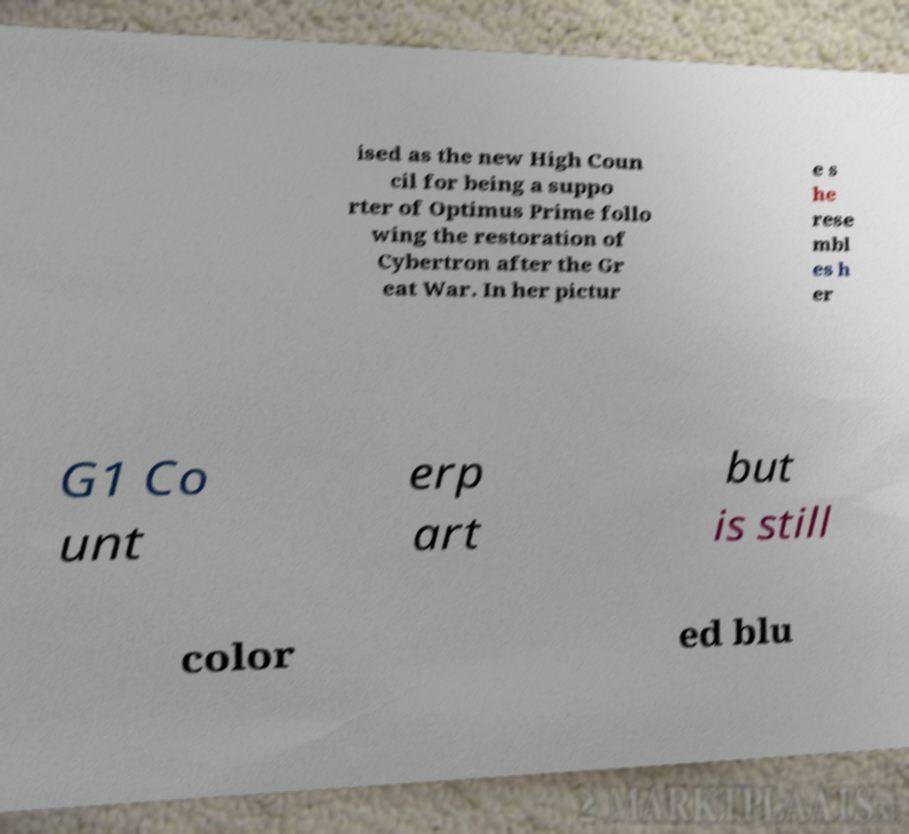Can you accurately transcribe the text from the provided image for me? ised as the new High Coun cil for being a suppo rter of Optimus Prime follo wing the restoration of Cybertron after the Gr eat War. In her pictur e s he rese mbl es h er G1 Co unt erp art but is still color ed blu 